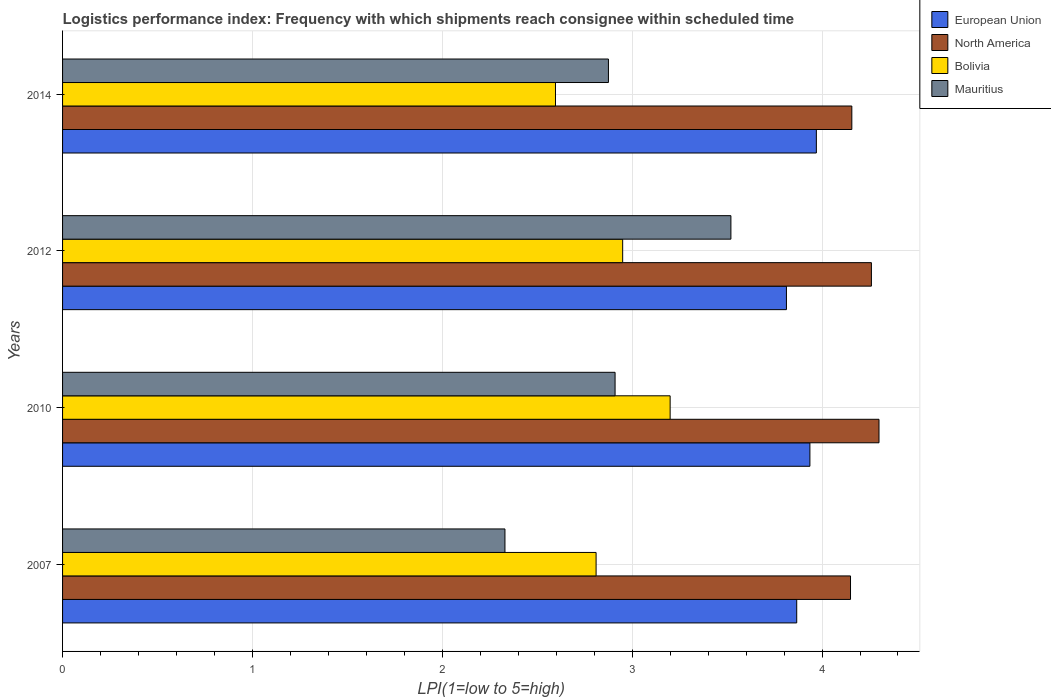How many different coloured bars are there?
Make the answer very short. 4. How many bars are there on the 1st tick from the bottom?
Provide a short and direct response. 4. What is the label of the 3rd group of bars from the top?
Keep it short and to the point. 2010. Across all years, what is the maximum logistics performance index in European Union?
Keep it short and to the point. 3.97. Across all years, what is the minimum logistics performance index in North America?
Keep it short and to the point. 4.15. In which year was the logistics performance index in North America maximum?
Offer a very short reply. 2010. In which year was the logistics performance index in Bolivia minimum?
Ensure brevity in your answer.  2014. What is the total logistics performance index in European Union in the graph?
Your answer should be very brief. 15.59. What is the difference between the logistics performance index in Bolivia in 2012 and that in 2014?
Provide a succinct answer. 0.35. What is the difference between the logistics performance index in European Union in 2010 and the logistics performance index in Bolivia in 2012?
Ensure brevity in your answer.  0.99. What is the average logistics performance index in European Union per year?
Keep it short and to the point. 3.9. In the year 2014, what is the difference between the logistics performance index in European Union and logistics performance index in Bolivia?
Provide a short and direct response. 1.37. What is the ratio of the logistics performance index in Mauritius in 2012 to that in 2014?
Offer a terse response. 1.22. What is the difference between the highest and the lowest logistics performance index in North America?
Give a very brief answer. 0.15. In how many years, is the logistics performance index in North America greater than the average logistics performance index in North America taken over all years?
Your answer should be compact. 2. Is the sum of the logistics performance index in Mauritius in 2007 and 2014 greater than the maximum logistics performance index in Bolivia across all years?
Your response must be concise. Yes. Is it the case that in every year, the sum of the logistics performance index in North America and logistics performance index in Mauritius is greater than the sum of logistics performance index in European Union and logistics performance index in Bolivia?
Make the answer very short. Yes. What does the 2nd bar from the top in 2010 represents?
Ensure brevity in your answer.  Bolivia. What does the 1st bar from the bottom in 2007 represents?
Make the answer very short. European Union. Is it the case that in every year, the sum of the logistics performance index in Bolivia and logistics performance index in European Union is greater than the logistics performance index in North America?
Your response must be concise. Yes. How many bars are there?
Ensure brevity in your answer.  16. Does the graph contain grids?
Provide a succinct answer. Yes. How are the legend labels stacked?
Your answer should be compact. Vertical. What is the title of the graph?
Keep it short and to the point. Logistics performance index: Frequency with which shipments reach consignee within scheduled time. Does "Iraq" appear as one of the legend labels in the graph?
Ensure brevity in your answer.  No. What is the label or title of the X-axis?
Your answer should be very brief. LPI(1=low to 5=high). What is the label or title of the Y-axis?
Offer a very short reply. Years. What is the LPI(1=low to 5=high) of European Union in 2007?
Provide a succinct answer. 3.87. What is the LPI(1=low to 5=high) in North America in 2007?
Your answer should be very brief. 4.15. What is the LPI(1=low to 5=high) of Bolivia in 2007?
Offer a terse response. 2.81. What is the LPI(1=low to 5=high) in Mauritius in 2007?
Your answer should be compact. 2.33. What is the LPI(1=low to 5=high) of European Union in 2010?
Your response must be concise. 3.94. What is the LPI(1=low to 5=high) in North America in 2010?
Make the answer very short. 4.3. What is the LPI(1=low to 5=high) in Mauritius in 2010?
Make the answer very short. 2.91. What is the LPI(1=low to 5=high) in European Union in 2012?
Your response must be concise. 3.81. What is the LPI(1=low to 5=high) in North America in 2012?
Provide a succinct answer. 4.26. What is the LPI(1=low to 5=high) of Bolivia in 2012?
Offer a terse response. 2.95. What is the LPI(1=low to 5=high) of Mauritius in 2012?
Give a very brief answer. 3.52. What is the LPI(1=low to 5=high) in European Union in 2014?
Offer a terse response. 3.97. What is the LPI(1=low to 5=high) of North America in 2014?
Provide a short and direct response. 4.16. What is the LPI(1=low to 5=high) in Bolivia in 2014?
Your answer should be very brief. 2.6. What is the LPI(1=low to 5=high) in Mauritius in 2014?
Make the answer very short. 2.88. Across all years, what is the maximum LPI(1=low to 5=high) of European Union?
Offer a very short reply. 3.97. Across all years, what is the maximum LPI(1=low to 5=high) in Bolivia?
Keep it short and to the point. 3.2. Across all years, what is the maximum LPI(1=low to 5=high) in Mauritius?
Your response must be concise. 3.52. Across all years, what is the minimum LPI(1=low to 5=high) in European Union?
Your response must be concise. 3.81. Across all years, what is the minimum LPI(1=low to 5=high) of North America?
Provide a short and direct response. 4.15. Across all years, what is the minimum LPI(1=low to 5=high) in Bolivia?
Keep it short and to the point. 2.6. Across all years, what is the minimum LPI(1=low to 5=high) in Mauritius?
Make the answer very short. 2.33. What is the total LPI(1=low to 5=high) of European Union in the graph?
Ensure brevity in your answer.  15.59. What is the total LPI(1=low to 5=high) of North America in the graph?
Keep it short and to the point. 16.87. What is the total LPI(1=low to 5=high) of Bolivia in the graph?
Offer a very short reply. 11.56. What is the total LPI(1=low to 5=high) of Mauritius in the graph?
Offer a terse response. 11.63. What is the difference between the LPI(1=low to 5=high) in European Union in 2007 and that in 2010?
Your answer should be compact. -0.07. What is the difference between the LPI(1=low to 5=high) in Bolivia in 2007 and that in 2010?
Your answer should be very brief. -0.39. What is the difference between the LPI(1=low to 5=high) of Mauritius in 2007 and that in 2010?
Your answer should be very brief. -0.58. What is the difference between the LPI(1=low to 5=high) of European Union in 2007 and that in 2012?
Make the answer very short. 0.05. What is the difference between the LPI(1=low to 5=high) in North America in 2007 and that in 2012?
Your answer should be very brief. -0.11. What is the difference between the LPI(1=low to 5=high) in Bolivia in 2007 and that in 2012?
Keep it short and to the point. -0.14. What is the difference between the LPI(1=low to 5=high) of Mauritius in 2007 and that in 2012?
Your answer should be compact. -1.19. What is the difference between the LPI(1=low to 5=high) of European Union in 2007 and that in 2014?
Provide a short and direct response. -0.1. What is the difference between the LPI(1=low to 5=high) of North America in 2007 and that in 2014?
Give a very brief answer. -0.01. What is the difference between the LPI(1=low to 5=high) of Bolivia in 2007 and that in 2014?
Your response must be concise. 0.21. What is the difference between the LPI(1=low to 5=high) in Mauritius in 2007 and that in 2014?
Ensure brevity in your answer.  -0.55. What is the difference between the LPI(1=low to 5=high) of European Union in 2010 and that in 2012?
Ensure brevity in your answer.  0.12. What is the difference between the LPI(1=low to 5=high) in Bolivia in 2010 and that in 2012?
Provide a succinct answer. 0.25. What is the difference between the LPI(1=low to 5=high) of Mauritius in 2010 and that in 2012?
Offer a very short reply. -0.61. What is the difference between the LPI(1=low to 5=high) of European Union in 2010 and that in 2014?
Offer a very short reply. -0.03. What is the difference between the LPI(1=low to 5=high) in North America in 2010 and that in 2014?
Make the answer very short. 0.14. What is the difference between the LPI(1=low to 5=high) in Bolivia in 2010 and that in 2014?
Offer a very short reply. 0.6. What is the difference between the LPI(1=low to 5=high) of Mauritius in 2010 and that in 2014?
Make the answer very short. 0.04. What is the difference between the LPI(1=low to 5=high) of European Union in 2012 and that in 2014?
Keep it short and to the point. -0.16. What is the difference between the LPI(1=low to 5=high) of North America in 2012 and that in 2014?
Your response must be concise. 0.1. What is the difference between the LPI(1=low to 5=high) of Bolivia in 2012 and that in 2014?
Offer a very short reply. 0.35. What is the difference between the LPI(1=low to 5=high) of Mauritius in 2012 and that in 2014?
Your response must be concise. 0.65. What is the difference between the LPI(1=low to 5=high) of European Union in 2007 and the LPI(1=low to 5=high) of North America in 2010?
Make the answer very short. -0.43. What is the difference between the LPI(1=low to 5=high) of European Union in 2007 and the LPI(1=low to 5=high) of Mauritius in 2010?
Make the answer very short. 0.96. What is the difference between the LPI(1=low to 5=high) in North America in 2007 and the LPI(1=low to 5=high) in Mauritius in 2010?
Provide a succinct answer. 1.24. What is the difference between the LPI(1=low to 5=high) of Bolivia in 2007 and the LPI(1=low to 5=high) of Mauritius in 2010?
Provide a short and direct response. -0.1. What is the difference between the LPI(1=low to 5=high) in European Union in 2007 and the LPI(1=low to 5=high) in North America in 2012?
Provide a succinct answer. -0.39. What is the difference between the LPI(1=low to 5=high) in European Union in 2007 and the LPI(1=low to 5=high) in Bolivia in 2012?
Your answer should be compact. 0.92. What is the difference between the LPI(1=low to 5=high) of European Union in 2007 and the LPI(1=low to 5=high) of Mauritius in 2012?
Make the answer very short. 0.35. What is the difference between the LPI(1=low to 5=high) of North America in 2007 and the LPI(1=low to 5=high) of Mauritius in 2012?
Offer a terse response. 0.63. What is the difference between the LPI(1=low to 5=high) of Bolivia in 2007 and the LPI(1=low to 5=high) of Mauritius in 2012?
Keep it short and to the point. -0.71. What is the difference between the LPI(1=low to 5=high) in European Union in 2007 and the LPI(1=low to 5=high) in North America in 2014?
Provide a short and direct response. -0.29. What is the difference between the LPI(1=low to 5=high) of European Union in 2007 and the LPI(1=low to 5=high) of Bolivia in 2014?
Ensure brevity in your answer.  1.27. What is the difference between the LPI(1=low to 5=high) in North America in 2007 and the LPI(1=low to 5=high) in Bolivia in 2014?
Make the answer very short. 1.55. What is the difference between the LPI(1=low to 5=high) of North America in 2007 and the LPI(1=low to 5=high) of Mauritius in 2014?
Provide a succinct answer. 1.27. What is the difference between the LPI(1=low to 5=high) of Bolivia in 2007 and the LPI(1=low to 5=high) of Mauritius in 2014?
Give a very brief answer. -0.07. What is the difference between the LPI(1=low to 5=high) of European Union in 2010 and the LPI(1=low to 5=high) of North America in 2012?
Provide a succinct answer. -0.32. What is the difference between the LPI(1=low to 5=high) of European Union in 2010 and the LPI(1=low to 5=high) of Bolivia in 2012?
Offer a terse response. 0.99. What is the difference between the LPI(1=low to 5=high) in European Union in 2010 and the LPI(1=low to 5=high) in Mauritius in 2012?
Give a very brief answer. 0.42. What is the difference between the LPI(1=low to 5=high) of North America in 2010 and the LPI(1=low to 5=high) of Bolivia in 2012?
Provide a succinct answer. 1.35. What is the difference between the LPI(1=low to 5=high) in North America in 2010 and the LPI(1=low to 5=high) in Mauritius in 2012?
Make the answer very short. 0.78. What is the difference between the LPI(1=low to 5=high) of Bolivia in 2010 and the LPI(1=low to 5=high) of Mauritius in 2012?
Ensure brevity in your answer.  -0.32. What is the difference between the LPI(1=low to 5=high) of European Union in 2010 and the LPI(1=low to 5=high) of North America in 2014?
Give a very brief answer. -0.22. What is the difference between the LPI(1=low to 5=high) in European Union in 2010 and the LPI(1=low to 5=high) in Bolivia in 2014?
Offer a terse response. 1.34. What is the difference between the LPI(1=low to 5=high) of European Union in 2010 and the LPI(1=low to 5=high) of Mauritius in 2014?
Your answer should be very brief. 1.06. What is the difference between the LPI(1=low to 5=high) in North America in 2010 and the LPI(1=low to 5=high) in Bolivia in 2014?
Your response must be concise. 1.7. What is the difference between the LPI(1=low to 5=high) in North America in 2010 and the LPI(1=low to 5=high) in Mauritius in 2014?
Provide a short and direct response. 1.43. What is the difference between the LPI(1=low to 5=high) in Bolivia in 2010 and the LPI(1=low to 5=high) in Mauritius in 2014?
Offer a terse response. 0.33. What is the difference between the LPI(1=low to 5=high) of European Union in 2012 and the LPI(1=low to 5=high) of North America in 2014?
Provide a succinct answer. -0.34. What is the difference between the LPI(1=low to 5=high) of European Union in 2012 and the LPI(1=low to 5=high) of Bolivia in 2014?
Provide a succinct answer. 1.22. What is the difference between the LPI(1=low to 5=high) of North America in 2012 and the LPI(1=low to 5=high) of Bolivia in 2014?
Your answer should be compact. 1.66. What is the difference between the LPI(1=low to 5=high) in North America in 2012 and the LPI(1=low to 5=high) in Mauritius in 2014?
Offer a terse response. 1.39. What is the difference between the LPI(1=low to 5=high) of Bolivia in 2012 and the LPI(1=low to 5=high) of Mauritius in 2014?
Provide a short and direct response. 0.07. What is the average LPI(1=low to 5=high) in European Union per year?
Your answer should be compact. 3.9. What is the average LPI(1=low to 5=high) of North America per year?
Your answer should be very brief. 4.22. What is the average LPI(1=low to 5=high) in Bolivia per year?
Provide a short and direct response. 2.89. What is the average LPI(1=low to 5=high) of Mauritius per year?
Keep it short and to the point. 2.91. In the year 2007, what is the difference between the LPI(1=low to 5=high) of European Union and LPI(1=low to 5=high) of North America?
Ensure brevity in your answer.  -0.28. In the year 2007, what is the difference between the LPI(1=low to 5=high) in European Union and LPI(1=low to 5=high) in Bolivia?
Ensure brevity in your answer.  1.06. In the year 2007, what is the difference between the LPI(1=low to 5=high) in European Union and LPI(1=low to 5=high) in Mauritius?
Keep it short and to the point. 1.54. In the year 2007, what is the difference between the LPI(1=low to 5=high) of North America and LPI(1=low to 5=high) of Bolivia?
Provide a short and direct response. 1.34. In the year 2007, what is the difference between the LPI(1=low to 5=high) of North America and LPI(1=low to 5=high) of Mauritius?
Ensure brevity in your answer.  1.82. In the year 2007, what is the difference between the LPI(1=low to 5=high) of Bolivia and LPI(1=low to 5=high) of Mauritius?
Your answer should be compact. 0.48. In the year 2010, what is the difference between the LPI(1=low to 5=high) of European Union and LPI(1=low to 5=high) of North America?
Make the answer very short. -0.36. In the year 2010, what is the difference between the LPI(1=low to 5=high) in European Union and LPI(1=low to 5=high) in Bolivia?
Your answer should be very brief. 0.74. In the year 2010, what is the difference between the LPI(1=low to 5=high) in European Union and LPI(1=low to 5=high) in Mauritius?
Your answer should be very brief. 1.03. In the year 2010, what is the difference between the LPI(1=low to 5=high) of North America and LPI(1=low to 5=high) of Bolivia?
Give a very brief answer. 1.1. In the year 2010, what is the difference between the LPI(1=low to 5=high) in North America and LPI(1=low to 5=high) in Mauritius?
Provide a short and direct response. 1.39. In the year 2010, what is the difference between the LPI(1=low to 5=high) of Bolivia and LPI(1=low to 5=high) of Mauritius?
Ensure brevity in your answer.  0.29. In the year 2012, what is the difference between the LPI(1=low to 5=high) of European Union and LPI(1=low to 5=high) of North America?
Provide a succinct answer. -0.45. In the year 2012, what is the difference between the LPI(1=low to 5=high) of European Union and LPI(1=low to 5=high) of Bolivia?
Your response must be concise. 0.86. In the year 2012, what is the difference between the LPI(1=low to 5=high) of European Union and LPI(1=low to 5=high) of Mauritius?
Provide a succinct answer. 0.29. In the year 2012, what is the difference between the LPI(1=low to 5=high) of North America and LPI(1=low to 5=high) of Bolivia?
Offer a terse response. 1.31. In the year 2012, what is the difference between the LPI(1=low to 5=high) in North America and LPI(1=low to 5=high) in Mauritius?
Your answer should be compact. 0.74. In the year 2012, what is the difference between the LPI(1=low to 5=high) of Bolivia and LPI(1=low to 5=high) of Mauritius?
Keep it short and to the point. -0.57. In the year 2014, what is the difference between the LPI(1=low to 5=high) in European Union and LPI(1=low to 5=high) in North America?
Provide a short and direct response. -0.19. In the year 2014, what is the difference between the LPI(1=low to 5=high) in European Union and LPI(1=low to 5=high) in Bolivia?
Your answer should be very brief. 1.37. In the year 2014, what is the difference between the LPI(1=low to 5=high) in European Union and LPI(1=low to 5=high) in Mauritius?
Provide a short and direct response. 1.1. In the year 2014, what is the difference between the LPI(1=low to 5=high) of North America and LPI(1=low to 5=high) of Bolivia?
Your answer should be compact. 1.56. In the year 2014, what is the difference between the LPI(1=low to 5=high) of North America and LPI(1=low to 5=high) of Mauritius?
Keep it short and to the point. 1.28. In the year 2014, what is the difference between the LPI(1=low to 5=high) in Bolivia and LPI(1=low to 5=high) in Mauritius?
Make the answer very short. -0.28. What is the ratio of the LPI(1=low to 5=high) of European Union in 2007 to that in 2010?
Offer a very short reply. 0.98. What is the ratio of the LPI(1=low to 5=high) of North America in 2007 to that in 2010?
Offer a terse response. 0.97. What is the ratio of the LPI(1=low to 5=high) in Bolivia in 2007 to that in 2010?
Ensure brevity in your answer.  0.88. What is the ratio of the LPI(1=low to 5=high) of Mauritius in 2007 to that in 2010?
Your response must be concise. 0.8. What is the ratio of the LPI(1=low to 5=high) of European Union in 2007 to that in 2012?
Give a very brief answer. 1.01. What is the ratio of the LPI(1=low to 5=high) in North America in 2007 to that in 2012?
Offer a very short reply. 0.97. What is the ratio of the LPI(1=low to 5=high) in Bolivia in 2007 to that in 2012?
Give a very brief answer. 0.95. What is the ratio of the LPI(1=low to 5=high) of Mauritius in 2007 to that in 2012?
Ensure brevity in your answer.  0.66. What is the ratio of the LPI(1=low to 5=high) in European Union in 2007 to that in 2014?
Your answer should be compact. 0.97. What is the ratio of the LPI(1=low to 5=high) in Bolivia in 2007 to that in 2014?
Keep it short and to the point. 1.08. What is the ratio of the LPI(1=low to 5=high) in Mauritius in 2007 to that in 2014?
Provide a succinct answer. 0.81. What is the ratio of the LPI(1=low to 5=high) of European Union in 2010 to that in 2012?
Offer a terse response. 1.03. What is the ratio of the LPI(1=low to 5=high) in North America in 2010 to that in 2012?
Your answer should be compact. 1.01. What is the ratio of the LPI(1=low to 5=high) in Bolivia in 2010 to that in 2012?
Make the answer very short. 1.08. What is the ratio of the LPI(1=low to 5=high) of Mauritius in 2010 to that in 2012?
Provide a succinct answer. 0.83. What is the ratio of the LPI(1=low to 5=high) in European Union in 2010 to that in 2014?
Your response must be concise. 0.99. What is the ratio of the LPI(1=low to 5=high) of North America in 2010 to that in 2014?
Offer a terse response. 1.03. What is the ratio of the LPI(1=low to 5=high) in Bolivia in 2010 to that in 2014?
Your answer should be compact. 1.23. What is the ratio of the LPI(1=low to 5=high) of Mauritius in 2010 to that in 2014?
Offer a very short reply. 1.01. What is the ratio of the LPI(1=low to 5=high) of European Union in 2012 to that in 2014?
Make the answer very short. 0.96. What is the ratio of the LPI(1=low to 5=high) in North America in 2012 to that in 2014?
Provide a succinct answer. 1.02. What is the ratio of the LPI(1=low to 5=high) in Bolivia in 2012 to that in 2014?
Provide a succinct answer. 1.14. What is the ratio of the LPI(1=low to 5=high) in Mauritius in 2012 to that in 2014?
Keep it short and to the point. 1.22. What is the difference between the highest and the second highest LPI(1=low to 5=high) in European Union?
Provide a short and direct response. 0.03. What is the difference between the highest and the second highest LPI(1=low to 5=high) in Mauritius?
Your response must be concise. 0.61. What is the difference between the highest and the lowest LPI(1=low to 5=high) of European Union?
Provide a succinct answer. 0.16. What is the difference between the highest and the lowest LPI(1=low to 5=high) in North America?
Offer a terse response. 0.15. What is the difference between the highest and the lowest LPI(1=low to 5=high) in Bolivia?
Your answer should be very brief. 0.6. What is the difference between the highest and the lowest LPI(1=low to 5=high) in Mauritius?
Offer a terse response. 1.19. 